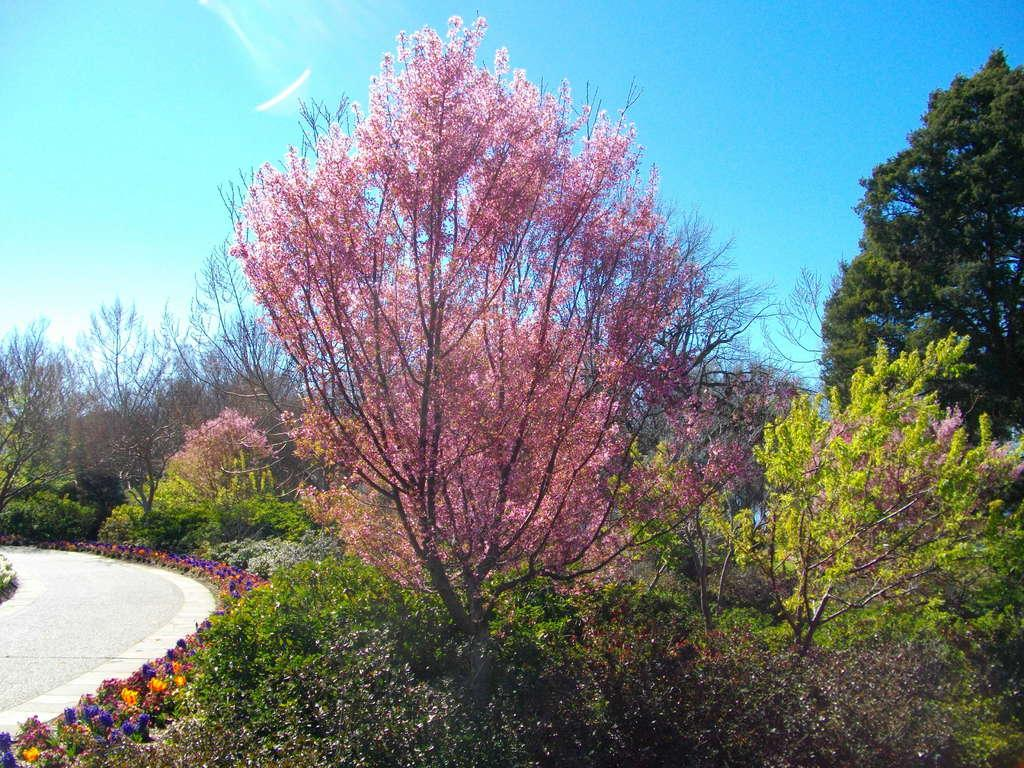What type of vegetation can be seen in the image? There are trees and plants with flowers in the image. What is unique about the flowers in the image? The flowers are of different colors. Is there any indication of a path or walkway in the image? Yes, there is a path visible in the image. What can be seen in the background of the image? The sky is blue in the background of the image. What type of cub is playing with a scale in the image? There is no cub or scale present in the image. What material is the linen made of in the image? There is no linen present in the image. 